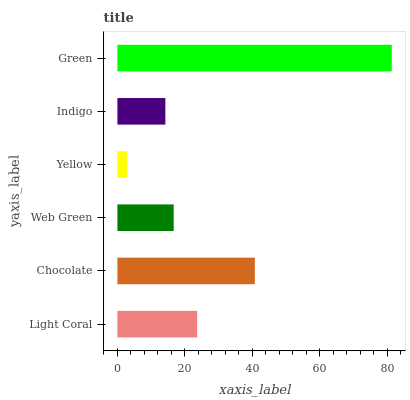Is Yellow the minimum?
Answer yes or no. Yes. Is Green the maximum?
Answer yes or no. Yes. Is Chocolate the minimum?
Answer yes or no. No. Is Chocolate the maximum?
Answer yes or no. No. Is Chocolate greater than Light Coral?
Answer yes or no. Yes. Is Light Coral less than Chocolate?
Answer yes or no. Yes. Is Light Coral greater than Chocolate?
Answer yes or no. No. Is Chocolate less than Light Coral?
Answer yes or no. No. Is Light Coral the high median?
Answer yes or no. Yes. Is Web Green the low median?
Answer yes or no. Yes. Is Yellow the high median?
Answer yes or no. No. Is Indigo the low median?
Answer yes or no. No. 